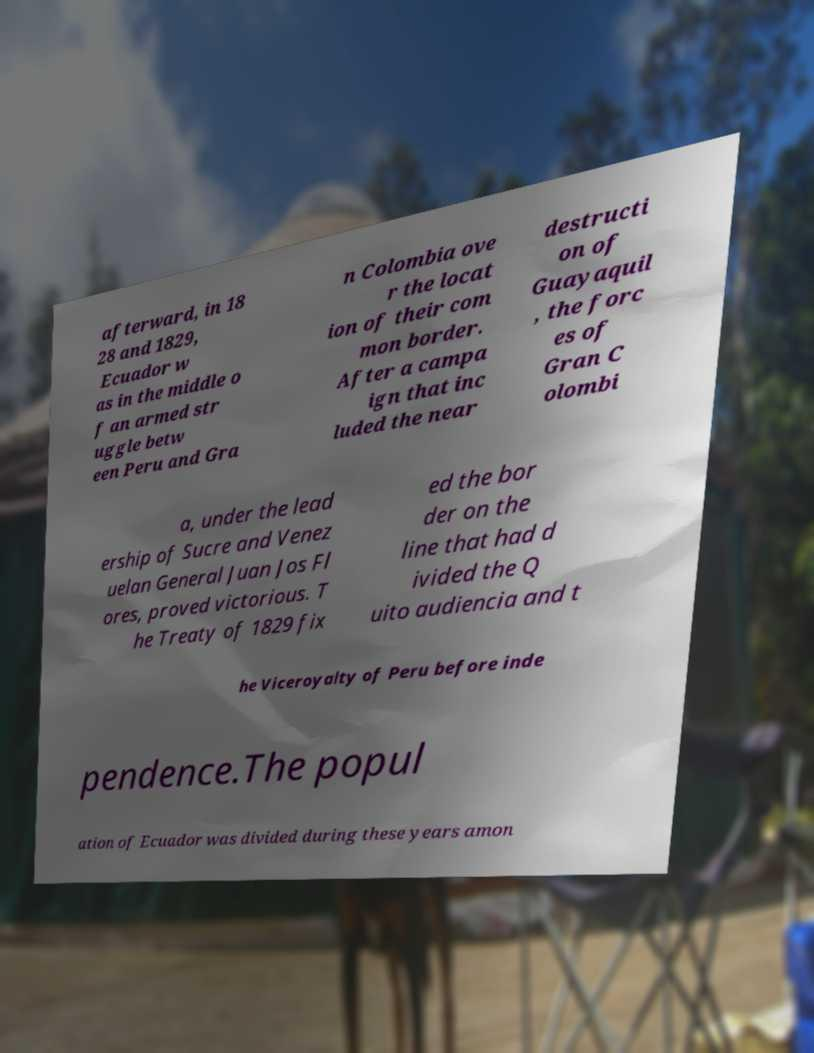Can you accurately transcribe the text from the provided image for me? afterward, in 18 28 and 1829, Ecuador w as in the middle o f an armed str uggle betw een Peru and Gra n Colombia ove r the locat ion of their com mon border. After a campa ign that inc luded the near destructi on of Guayaquil , the forc es of Gran C olombi a, under the lead ership of Sucre and Venez uelan General Juan Jos Fl ores, proved victorious. T he Treaty of 1829 fix ed the bor der on the line that had d ivided the Q uito audiencia and t he Viceroyalty of Peru before inde pendence.The popul ation of Ecuador was divided during these years amon 